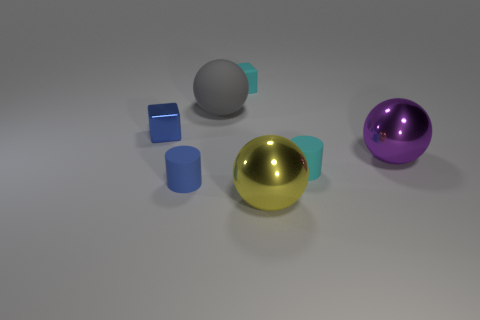Subtract all metal balls. How many balls are left? 1 Add 3 tiny matte cubes. How many objects exist? 10 Subtract all cylinders. How many objects are left? 5 Subtract all small brown shiny spheres. Subtract all small metallic blocks. How many objects are left? 6 Add 2 rubber objects. How many rubber objects are left? 6 Add 3 big cylinders. How many big cylinders exist? 3 Subtract 0 brown spheres. How many objects are left? 7 Subtract all blue cylinders. Subtract all gray spheres. How many cylinders are left? 1 